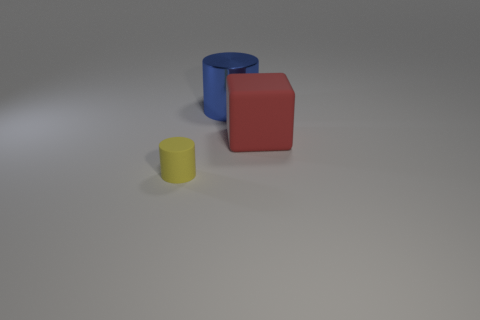Subtract all cylinders. How many objects are left? 1 Add 3 large red blocks. How many objects exist? 6 Add 3 tiny brown things. How many tiny brown things exist? 3 Subtract 1 blue cylinders. How many objects are left? 2 Subtract all tiny yellow things. Subtract all big metal objects. How many objects are left? 1 Add 3 matte cylinders. How many matte cylinders are left? 4 